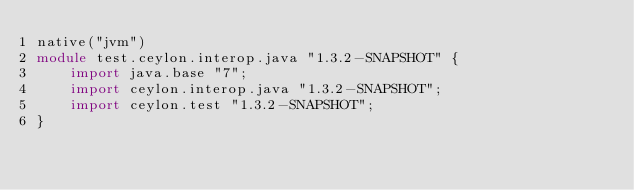<code> <loc_0><loc_0><loc_500><loc_500><_Ceylon_>native("jvm")
module test.ceylon.interop.java "1.3.2-SNAPSHOT" {
    import java.base "7";
    import ceylon.interop.java "1.3.2-SNAPSHOT";
    import ceylon.test "1.3.2-SNAPSHOT";
}
</code> 